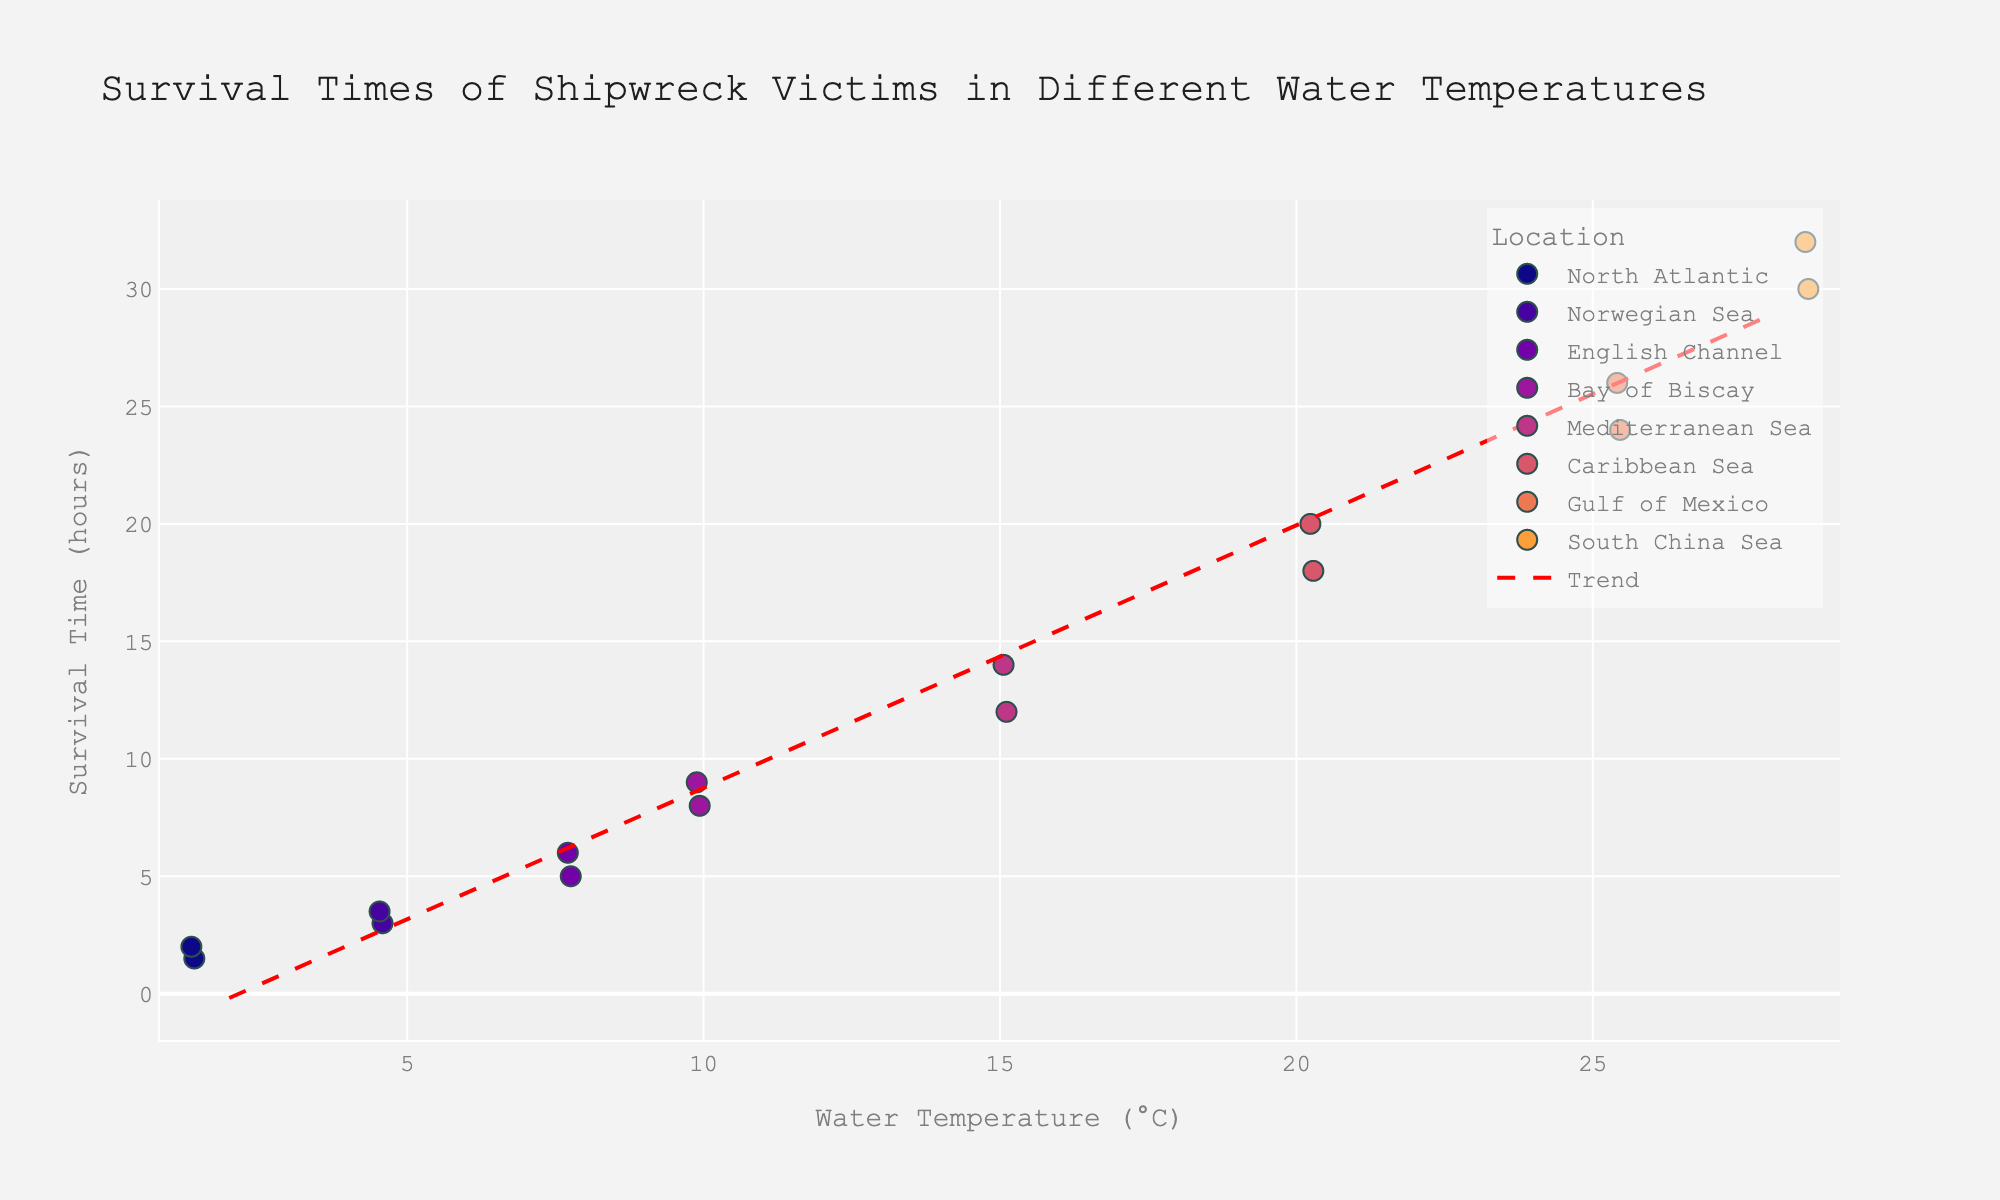What's the title of the figure? Look at the top of the figure where the title is displayed prominently.
Answer: Survival Times of Shipwreck Victims in Different Water Temperatures How many data points are there in total? Count all the individual points shown in the strip plot. Each point represents a data entry from the dataset.
Answer: 16 Which location has victims with the longest survival times? Identify the highest y-values on the strip plot and see which location they correspond to in the color legend.
Answer: South China Sea What is the overall trend between water temperature and survival time? Look at the direction and slope of the trend line added to the plot. A positive slope indicates that survival time increases with water temperature.
Answer: Survival time increases with water temperature How does the survival time of shipwreck victims in the North Atlantic compare to those in the Gulf of Mexico? Compare the range of survival times (y-values) for North Atlantic and Gulf of Mexico by looking at their respective data points.
Answer: Gulf of Mexico has much longer survival times Which water temperature range exhibits the greatest variation in survival times? Observe the spread of data points along the y-axis for different water temperature ranges, noting where the widest spread occurs.
Answer: 25-28°C What are the survival times for victims in the English Channel? Identify the points corresponding to the English Channel on the strip plot and read their y-values.
Answer: 5 and 6 hours What is the difference in survival times between the coldest and warmest water temperatures? Find the survival times for the coldest (2°C) and warmest (28°C) water temperatures and calculate their difference.
Answer: 30.5 hours What is the average survival time for the Norwegian Sea? Identify the data points for the Norwegian Sea, sum their survival times, and then divide by the number of data points.
Answer: 3.25 hours Which water temperature has the highest density of survival times? Look for the water temperature with the most clustered points along the y-axis, indicating higher density.
Answer: 25°C 